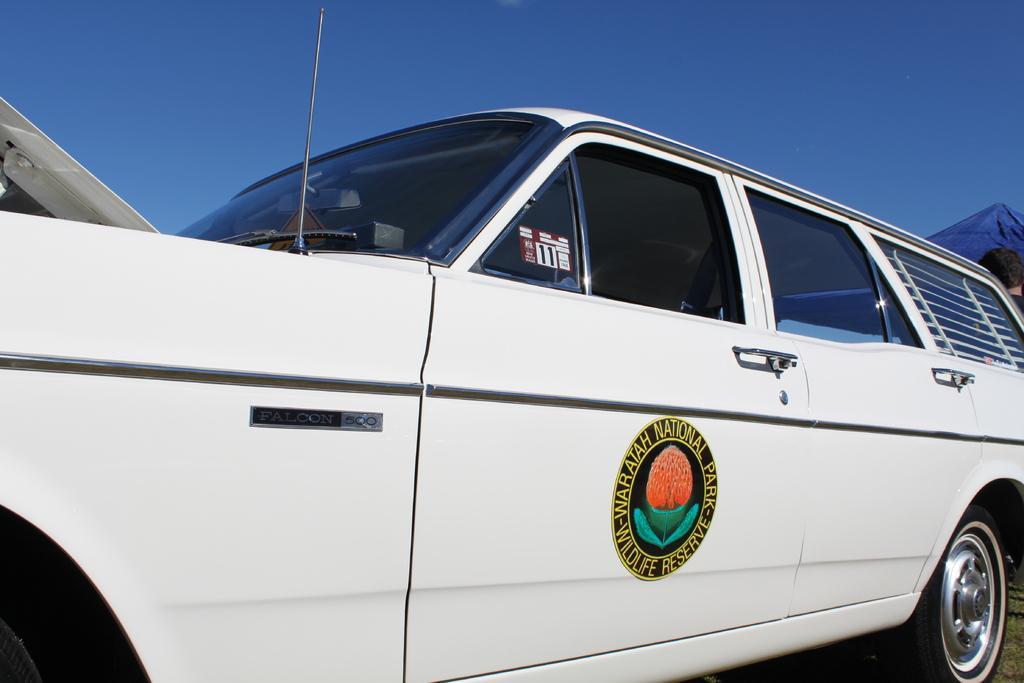Could you give a brief overview of what you see in this image? This picture contains a car which is white in color. On the door of the car, we see the sticker of wildlife reserve is pasted. At the top of the picture, we see the sky, which is blue in color. On the right side, we see the man standing and we even see the hill. 